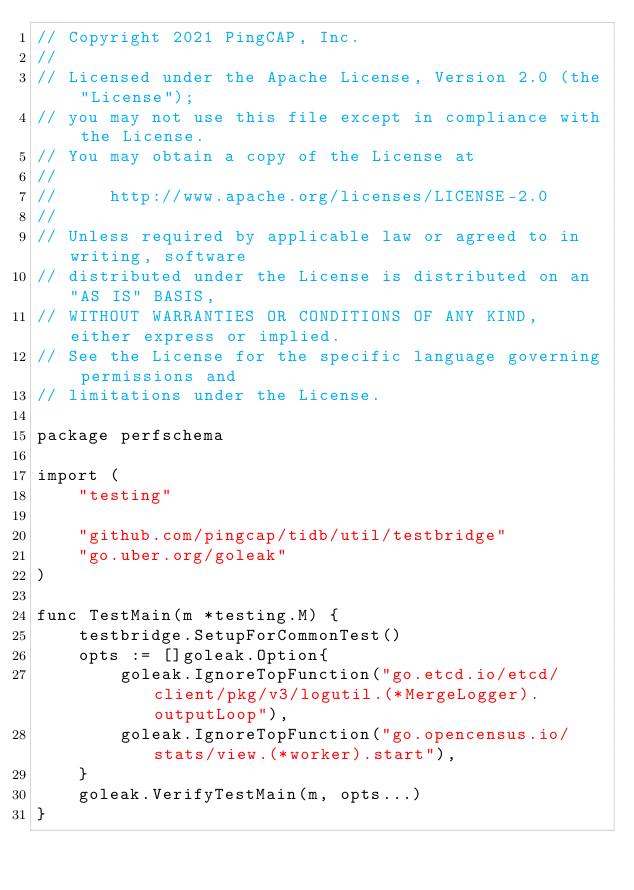Convert code to text. <code><loc_0><loc_0><loc_500><loc_500><_Go_>// Copyright 2021 PingCAP, Inc.
//
// Licensed under the Apache License, Version 2.0 (the "License");
// you may not use this file except in compliance with the License.
// You may obtain a copy of the License at
//
//     http://www.apache.org/licenses/LICENSE-2.0
//
// Unless required by applicable law or agreed to in writing, software
// distributed under the License is distributed on an "AS IS" BASIS,
// WITHOUT WARRANTIES OR CONDITIONS OF ANY KIND, either express or implied.
// See the License for the specific language governing permissions and
// limitations under the License.

package perfschema

import (
	"testing"

	"github.com/pingcap/tidb/util/testbridge"
	"go.uber.org/goleak"
)

func TestMain(m *testing.M) {
	testbridge.SetupForCommonTest()
	opts := []goleak.Option{
		goleak.IgnoreTopFunction("go.etcd.io/etcd/client/pkg/v3/logutil.(*MergeLogger).outputLoop"),
		goleak.IgnoreTopFunction("go.opencensus.io/stats/view.(*worker).start"),
	}
	goleak.VerifyTestMain(m, opts...)
}
</code> 